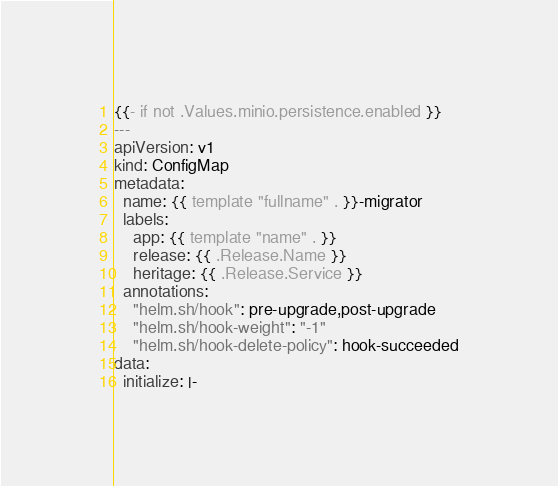Convert code to text. <code><loc_0><loc_0><loc_500><loc_500><_YAML_>{{- if not .Values.minio.persistence.enabled }}
---
apiVersion: v1
kind: ConfigMap
metadata:
  name: {{ template "fullname" . }}-migrator
  labels:
    app: {{ template "name" . }}
    release: {{ .Release.Name }}
    heritage: {{ .Release.Service }}
  annotations:
    "helm.sh/hook": pre-upgrade,post-upgrade
    "helm.sh/hook-weight": "-1"
    "helm.sh/hook-delete-policy": hook-succeeded
data:
  initialize: |-</code> 